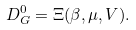Convert formula to latex. <formula><loc_0><loc_0><loc_500><loc_500>D _ { G } ^ { 0 } = \Xi ( \beta , \mu , V ) .</formula> 